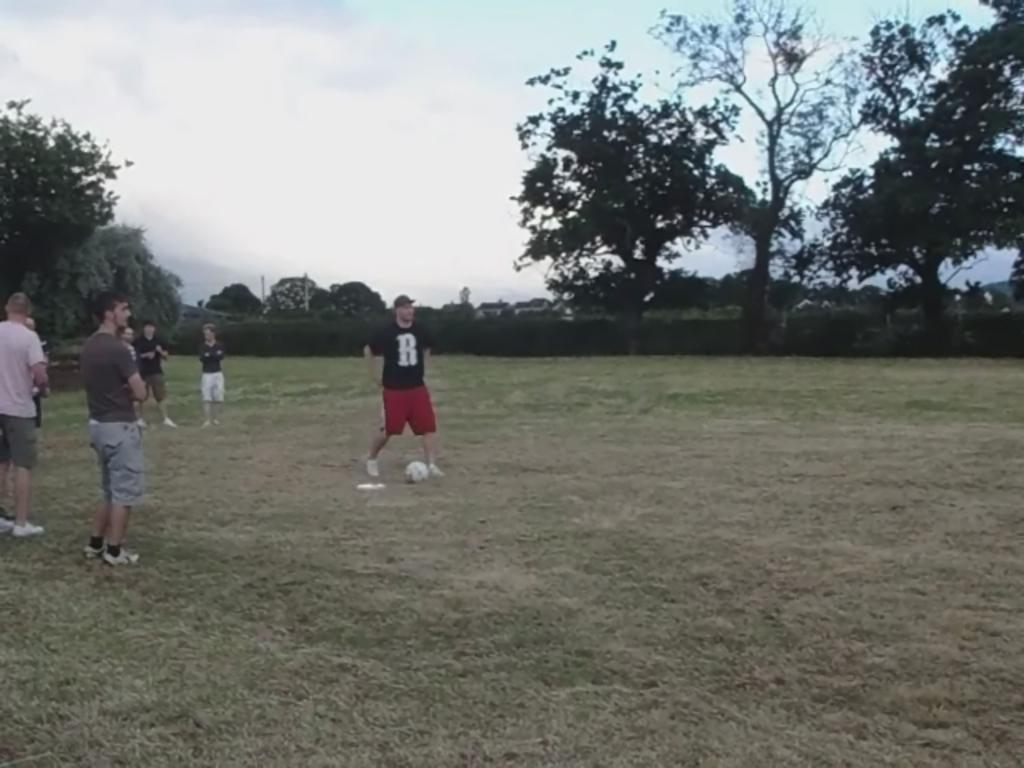What is happening in the image? There are people standing in the image. What is on the ground near the people? There is a ball on the ground in the image. What can be seen in the distance behind the people? There are trees, buildings, poles, and fences in the background of the image, as well as the sky. What is the condition of the sky in the image? The sky is visible in the background of the image, and clouds are present. How many ants are crawling on the ball in the image? There are no ants present in the image, so it is not possible to determine how many might be crawling on the ball. What time is indicated by the clock in the image? There is no clock present in the image, so it is not possible to determine the time. 